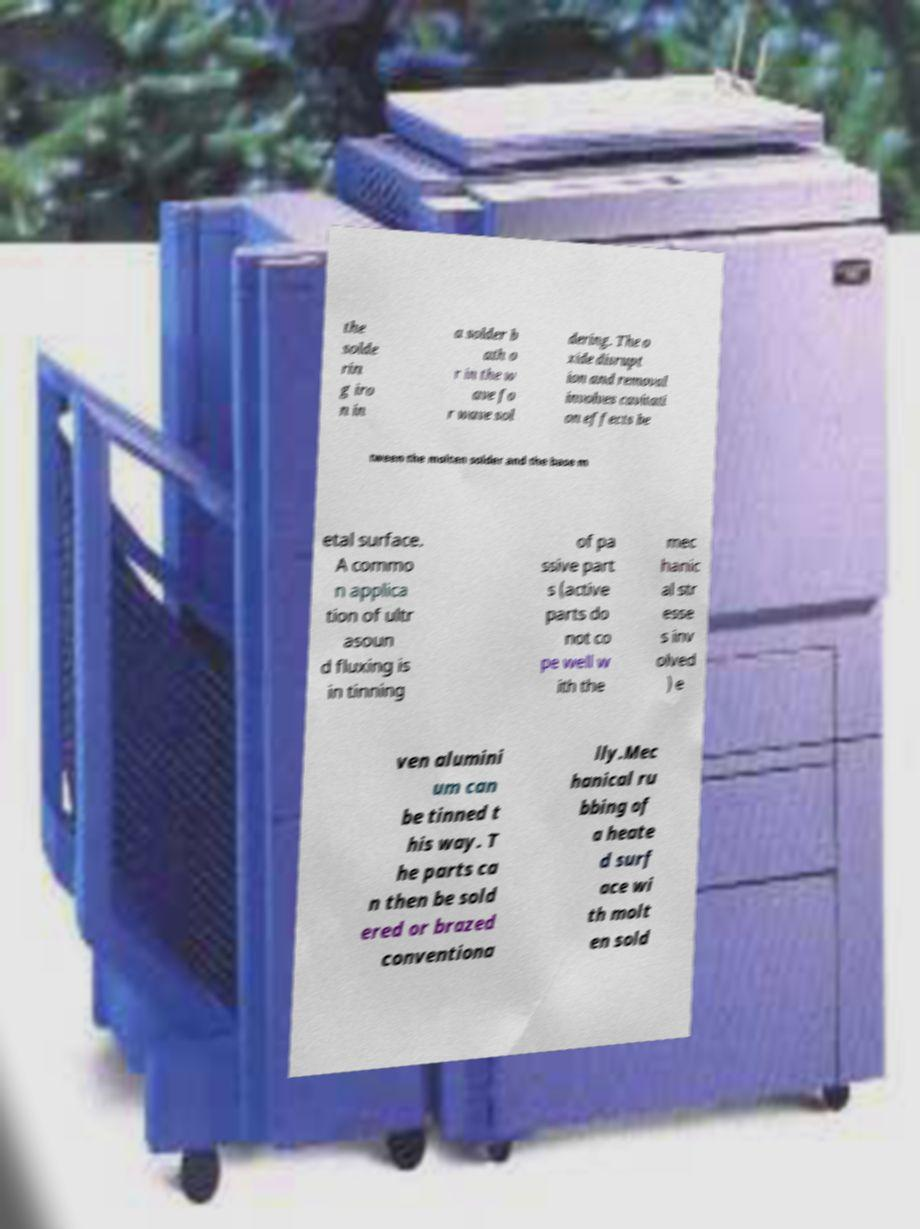Could you assist in decoding the text presented in this image and type it out clearly? the solde rin g iro n in a solder b ath o r in the w ave fo r wave sol dering. The o xide disrupt ion and removal involves cavitati on effects be tween the molten solder and the base m etal surface. A commo n applica tion of ultr asoun d fluxing is in tinning of pa ssive part s (active parts do not co pe well w ith the mec hanic al str esse s inv olved ) e ven alumini um can be tinned t his way. T he parts ca n then be sold ered or brazed conventiona lly.Mec hanical ru bbing of a heate d surf ace wi th molt en sold 